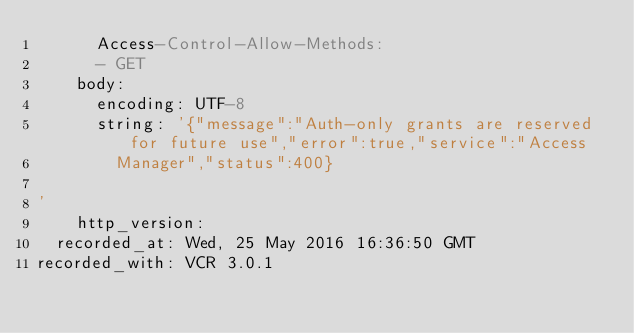Convert code to text. <code><loc_0><loc_0><loc_500><loc_500><_YAML_>      Access-Control-Allow-Methods:
      - GET
    body:
      encoding: UTF-8
      string: '{"message":"Auth-only grants are reserved for future use","error":true,"service":"Access
        Manager","status":400}

'
    http_version: 
  recorded_at: Wed, 25 May 2016 16:36:50 GMT
recorded_with: VCR 3.0.1
</code> 